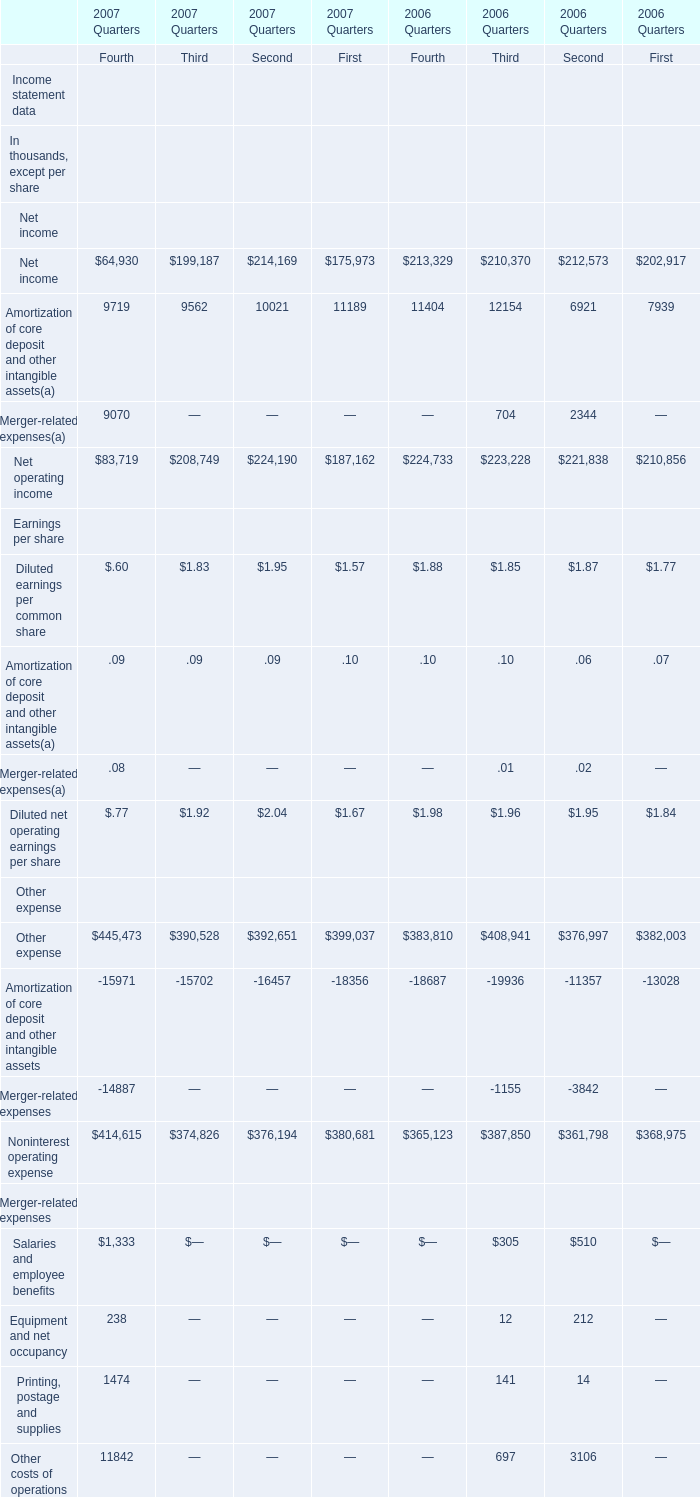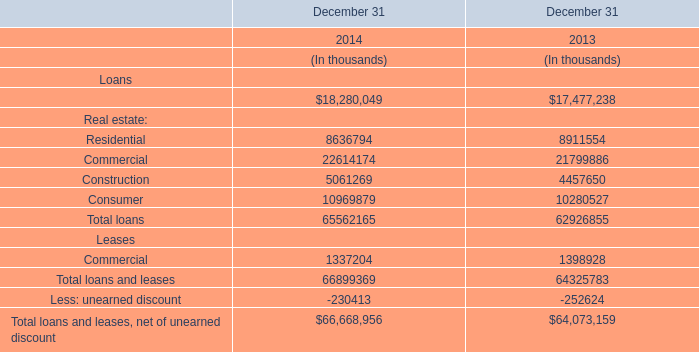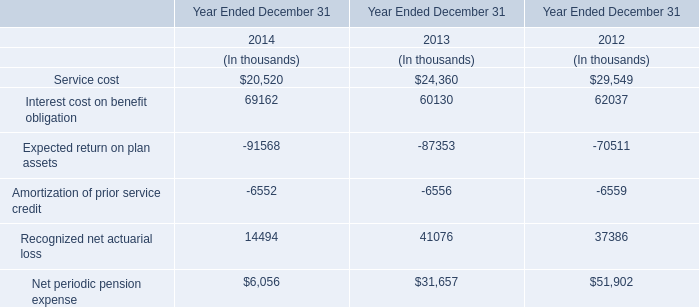In Quarter what of 2006 is the Salaries and employee benefits greater than 500 thousand? 
Answer: 2. 